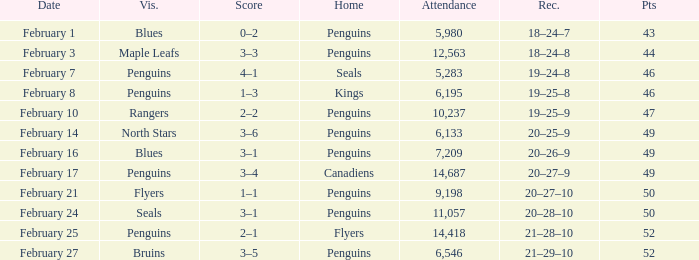Record of 21–29–10 had what total number of points? 1.0. 